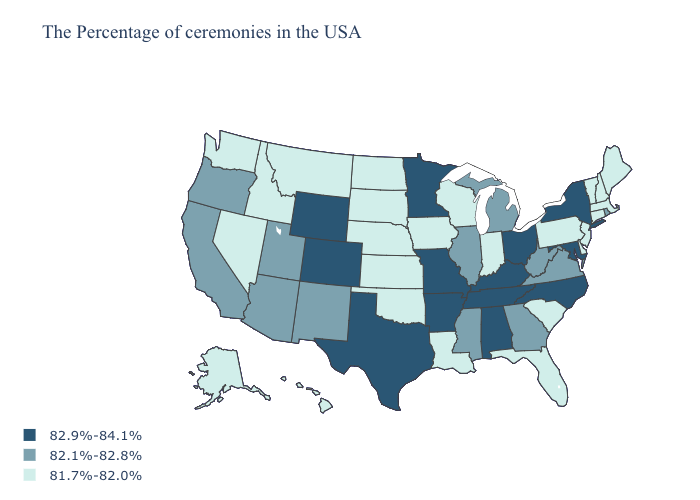Does South Carolina have a lower value than Oklahoma?
Answer briefly. No. Does the first symbol in the legend represent the smallest category?
Answer briefly. No. Does Louisiana have the highest value in the USA?
Quick response, please. No. What is the value of Louisiana?
Be succinct. 81.7%-82.0%. Name the states that have a value in the range 81.7%-82.0%?
Be succinct. Maine, Massachusetts, New Hampshire, Vermont, Connecticut, New Jersey, Delaware, Pennsylvania, South Carolina, Florida, Indiana, Wisconsin, Louisiana, Iowa, Kansas, Nebraska, Oklahoma, South Dakota, North Dakota, Montana, Idaho, Nevada, Washington, Alaska, Hawaii. What is the value of Vermont?
Answer briefly. 81.7%-82.0%. Name the states that have a value in the range 82.9%-84.1%?
Be succinct. New York, Maryland, North Carolina, Ohio, Kentucky, Alabama, Tennessee, Missouri, Arkansas, Minnesota, Texas, Wyoming, Colorado. Name the states that have a value in the range 82.9%-84.1%?
Give a very brief answer. New York, Maryland, North Carolina, Ohio, Kentucky, Alabama, Tennessee, Missouri, Arkansas, Minnesota, Texas, Wyoming, Colorado. Name the states that have a value in the range 81.7%-82.0%?
Short answer required. Maine, Massachusetts, New Hampshire, Vermont, Connecticut, New Jersey, Delaware, Pennsylvania, South Carolina, Florida, Indiana, Wisconsin, Louisiana, Iowa, Kansas, Nebraska, Oklahoma, South Dakota, North Dakota, Montana, Idaho, Nevada, Washington, Alaska, Hawaii. Does North Carolina have a higher value than Missouri?
Be succinct. No. Name the states that have a value in the range 81.7%-82.0%?
Answer briefly. Maine, Massachusetts, New Hampshire, Vermont, Connecticut, New Jersey, Delaware, Pennsylvania, South Carolina, Florida, Indiana, Wisconsin, Louisiana, Iowa, Kansas, Nebraska, Oklahoma, South Dakota, North Dakota, Montana, Idaho, Nevada, Washington, Alaska, Hawaii. What is the lowest value in states that border New York?
Be succinct. 81.7%-82.0%. Name the states that have a value in the range 81.7%-82.0%?
Concise answer only. Maine, Massachusetts, New Hampshire, Vermont, Connecticut, New Jersey, Delaware, Pennsylvania, South Carolina, Florida, Indiana, Wisconsin, Louisiana, Iowa, Kansas, Nebraska, Oklahoma, South Dakota, North Dakota, Montana, Idaho, Nevada, Washington, Alaska, Hawaii. Does West Virginia have a lower value than South Carolina?
Concise answer only. No. Name the states that have a value in the range 81.7%-82.0%?
Write a very short answer. Maine, Massachusetts, New Hampshire, Vermont, Connecticut, New Jersey, Delaware, Pennsylvania, South Carolina, Florida, Indiana, Wisconsin, Louisiana, Iowa, Kansas, Nebraska, Oklahoma, South Dakota, North Dakota, Montana, Idaho, Nevada, Washington, Alaska, Hawaii. 